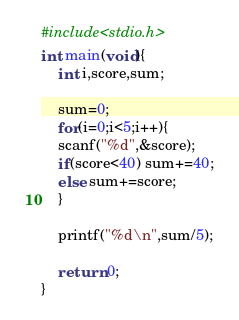<code> <loc_0><loc_0><loc_500><loc_500><_C_>#include<stdio.h>
int main(void){
    int i,score,sum;

    sum=0;
    for(i=0;i<5;i++){
	scanf("%d",&score);
	if(score<40) sum+=40;
	else sum+=score;
    }

    printf("%d\n",sum/5);

    return 0;
}</code> 